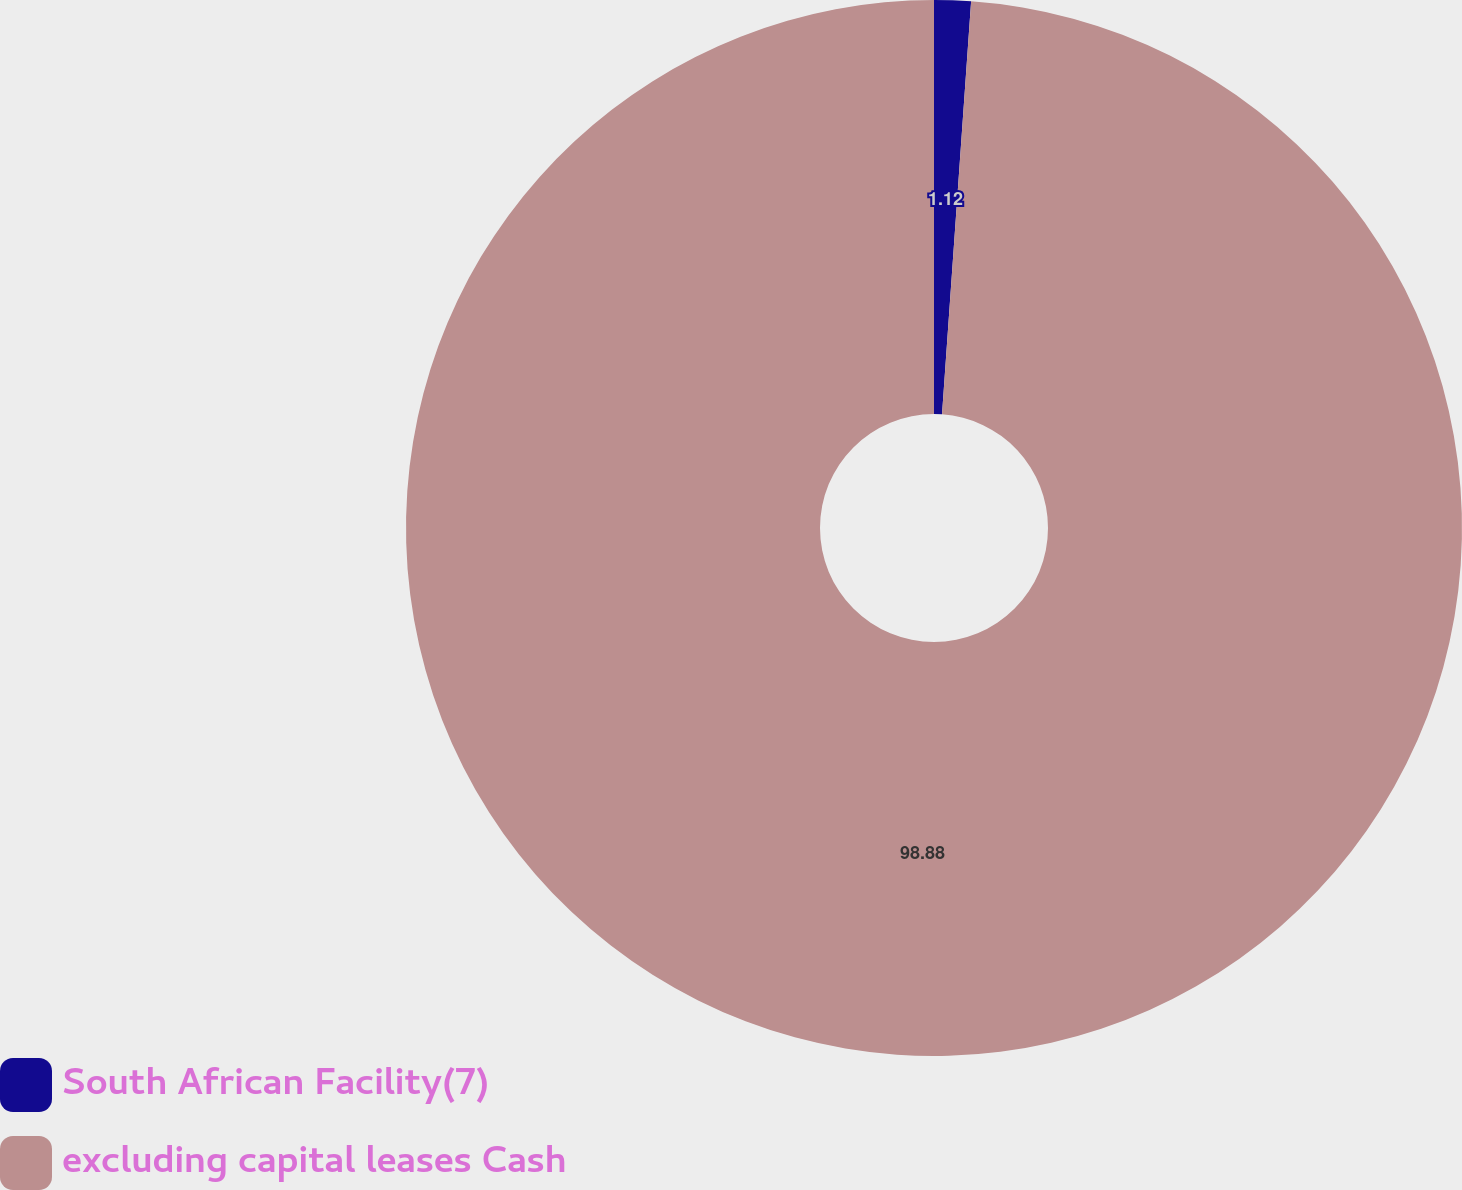<chart> <loc_0><loc_0><loc_500><loc_500><pie_chart><fcel>South African Facility(7)<fcel>excluding capital leases Cash<nl><fcel>1.12%<fcel>98.88%<nl></chart> 